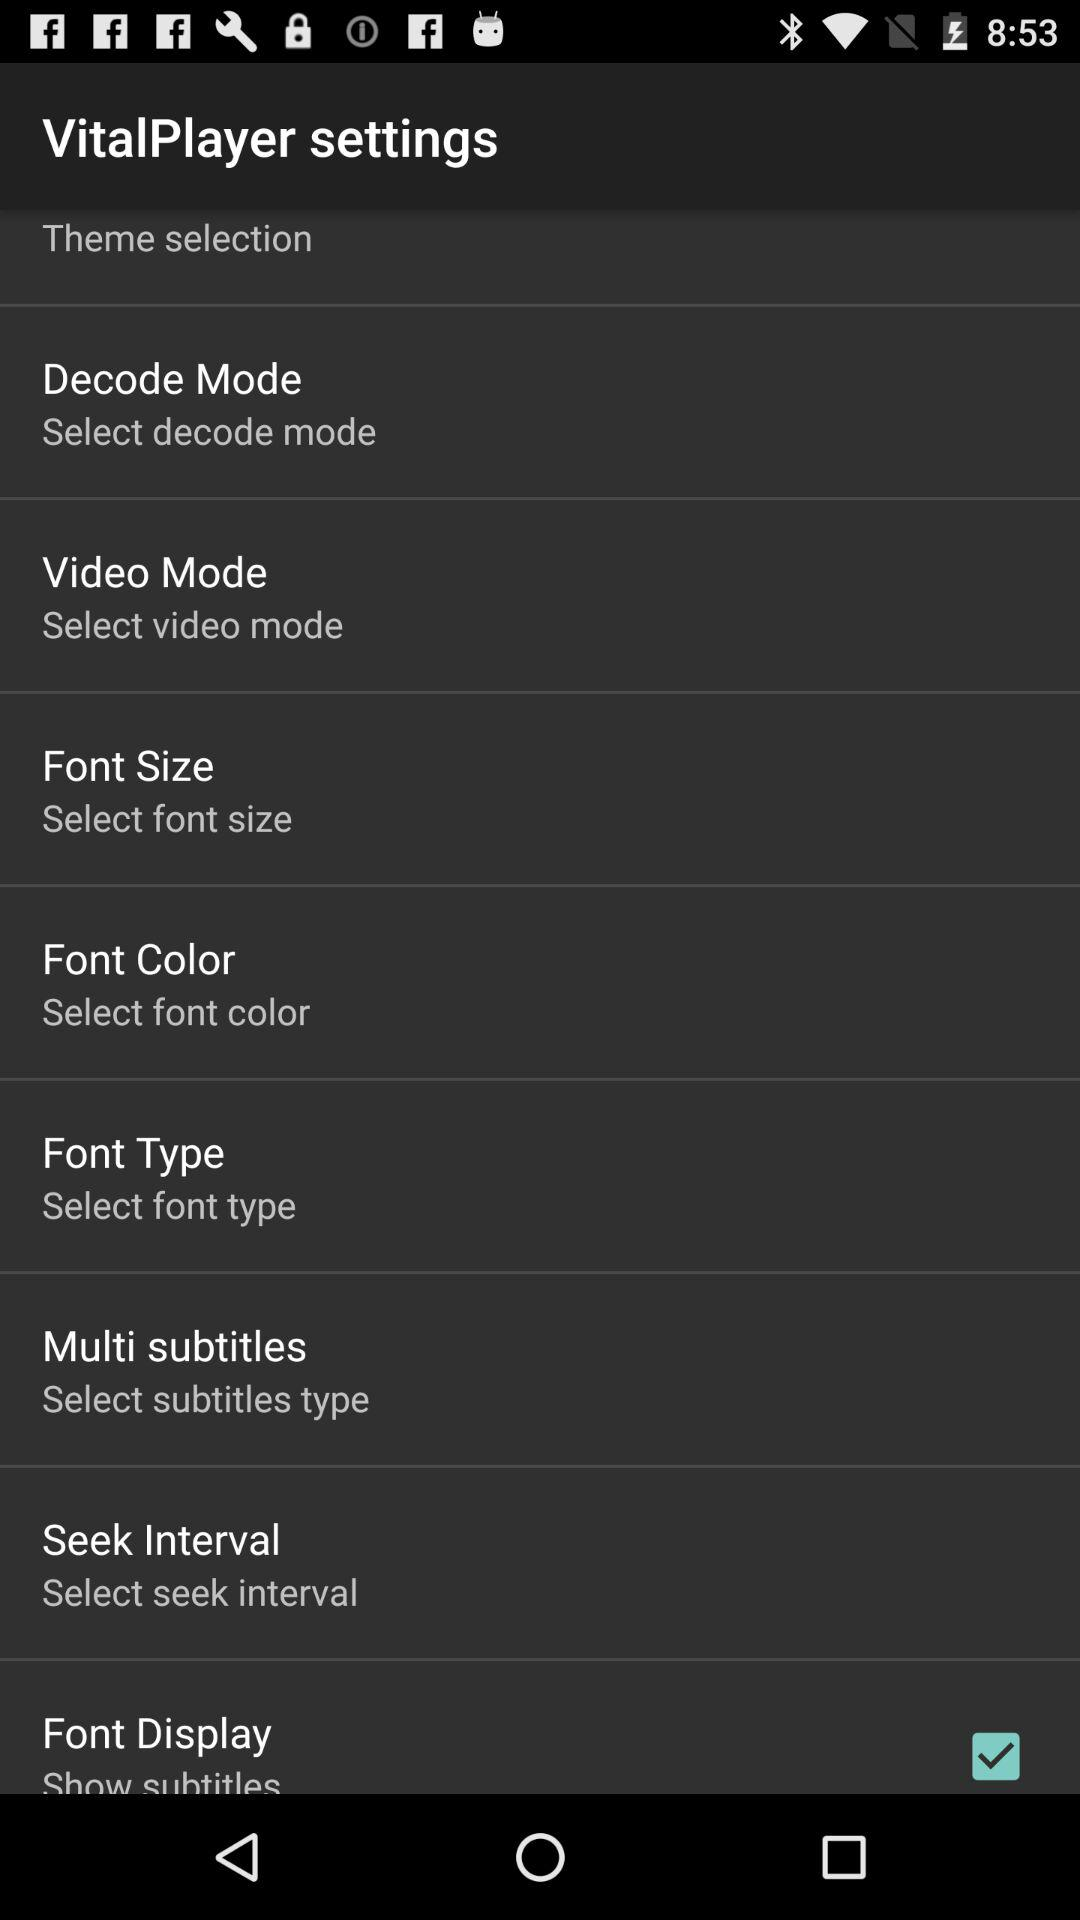Can you tell me more about the 'Decode Mode' and 'Video Mode' settings in VitalPlayer? 'Decode Mode' in VitalPlayer likely refers to the method the player uses to decode video files, which could include hardware acceleration options to improve playback performance. 'Video Mode' might involve settings that adjust video playback quality, aspect ratio, or screen brightness to cater to different viewing conditions. 